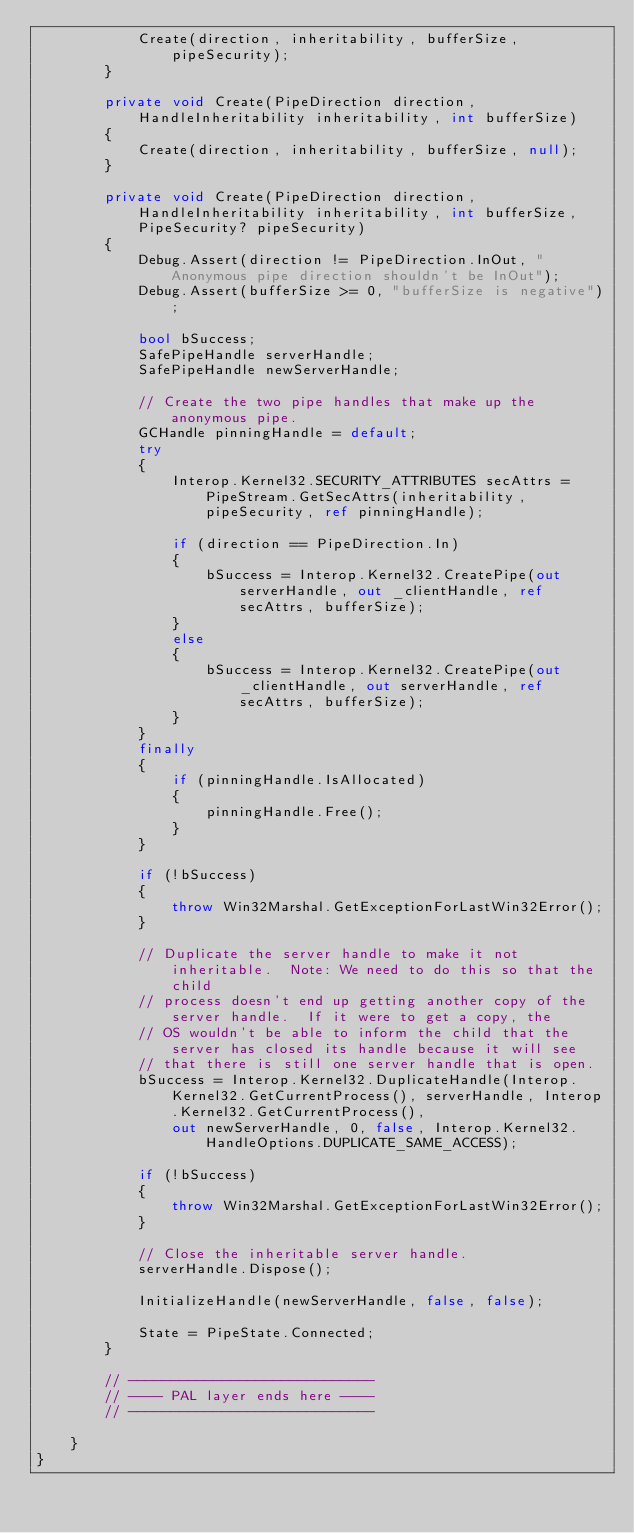<code> <loc_0><loc_0><loc_500><loc_500><_C#_>            Create(direction, inheritability, bufferSize, pipeSecurity);
        }

        private void Create(PipeDirection direction, HandleInheritability inheritability, int bufferSize)
        {
            Create(direction, inheritability, bufferSize, null);
        }

        private void Create(PipeDirection direction, HandleInheritability inheritability, int bufferSize, PipeSecurity? pipeSecurity)
        {
            Debug.Assert(direction != PipeDirection.InOut, "Anonymous pipe direction shouldn't be InOut");
            Debug.Assert(bufferSize >= 0, "bufferSize is negative");

            bool bSuccess;
            SafePipeHandle serverHandle;
            SafePipeHandle newServerHandle;

            // Create the two pipe handles that make up the anonymous pipe.
            GCHandle pinningHandle = default;
            try
            {
                Interop.Kernel32.SECURITY_ATTRIBUTES secAttrs = PipeStream.GetSecAttrs(inheritability, pipeSecurity, ref pinningHandle);

                if (direction == PipeDirection.In)
                {
                    bSuccess = Interop.Kernel32.CreatePipe(out serverHandle, out _clientHandle, ref secAttrs, bufferSize);
                }
                else
                {
                    bSuccess = Interop.Kernel32.CreatePipe(out _clientHandle, out serverHandle, ref secAttrs, bufferSize);
                }
            }
            finally
            {
                if (pinningHandle.IsAllocated)
                {
                    pinningHandle.Free();
                }
            }

            if (!bSuccess)
            {
                throw Win32Marshal.GetExceptionForLastWin32Error();
            }

            // Duplicate the server handle to make it not inheritable.  Note: We need to do this so that the child
            // process doesn't end up getting another copy of the server handle.  If it were to get a copy, the
            // OS wouldn't be able to inform the child that the server has closed its handle because it will see
            // that there is still one server handle that is open.
            bSuccess = Interop.Kernel32.DuplicateHandle(Interop.Kernel32.GetCurrentProcess(), serverHandle, Interop.Kernel32.GetCurrentProcess(),
                out newServerHandle, 0, false, Interop.Kernel32.HandleOptions.DUPLICATE_SAME_ACCESS);

            if (!bSuccess)
            {
                throw Win32Marshal.GetExceptionForLastWin32Error();
            }

            // Close the inheritable server handle.
            serverHandle.Dispose();

            InitializeHandle(newServerHandle, false, false);

            State = PipeState.Connected;
        }

        // -----------------------------
        // ---- PAL layer ends here ----
        // -----------------------------

    }
}
</code> 